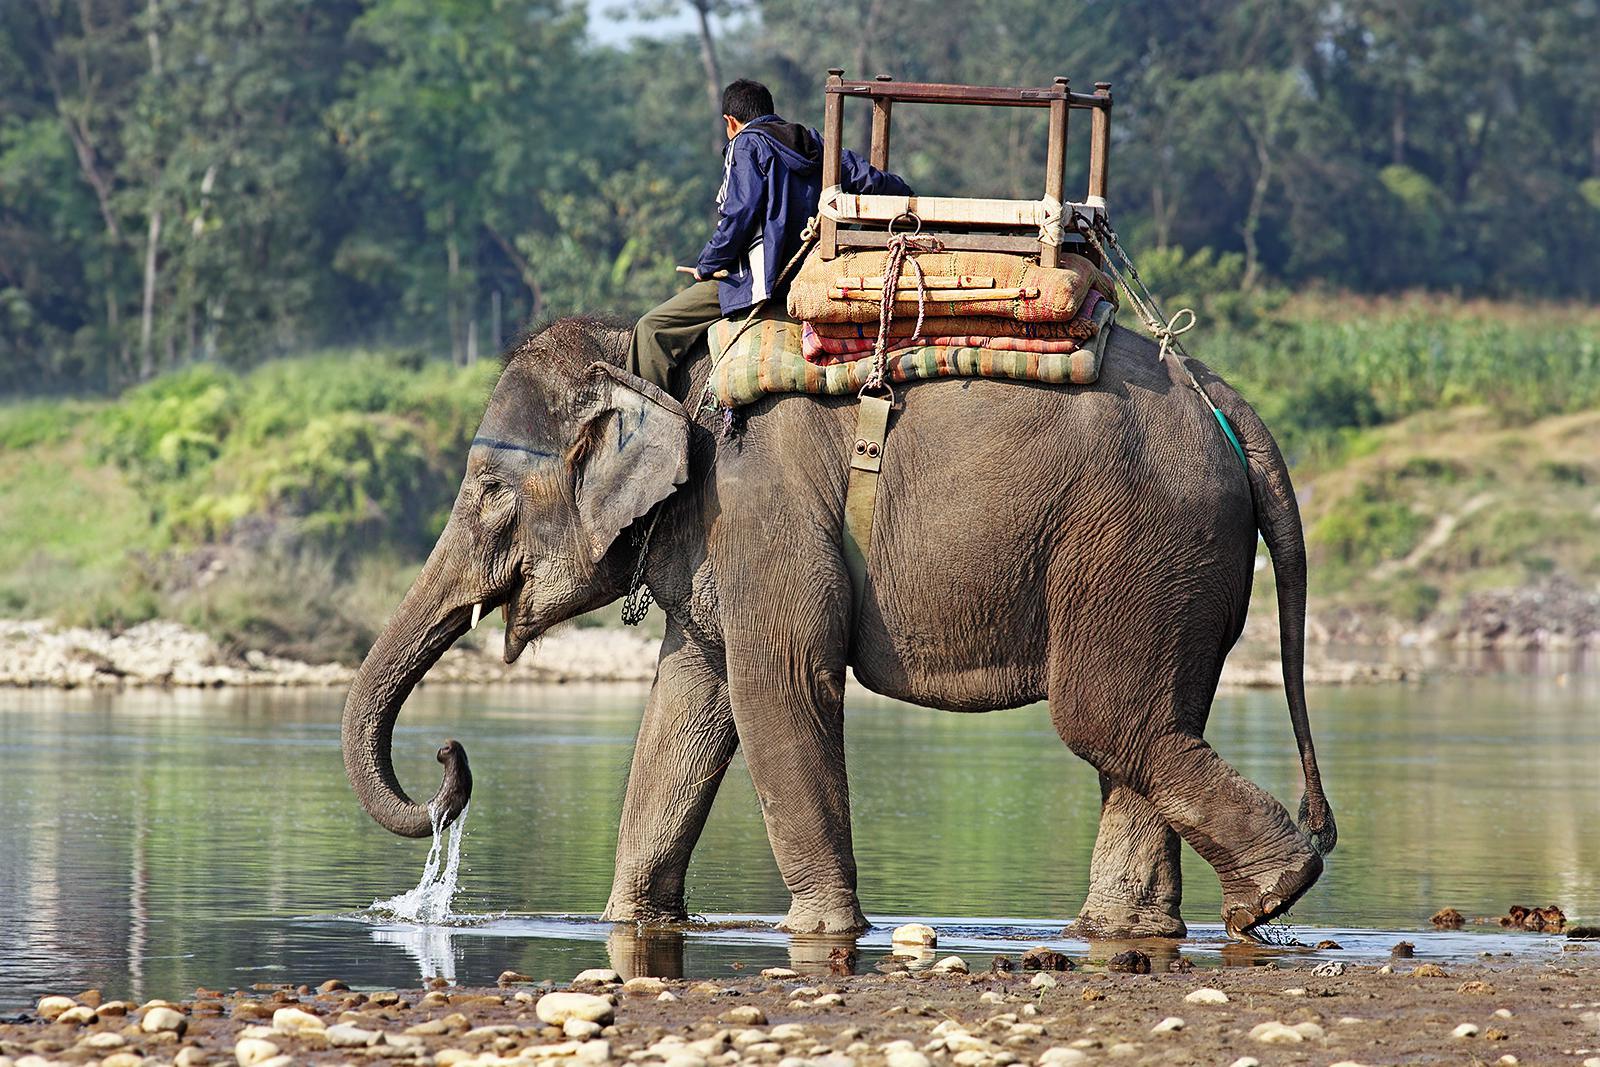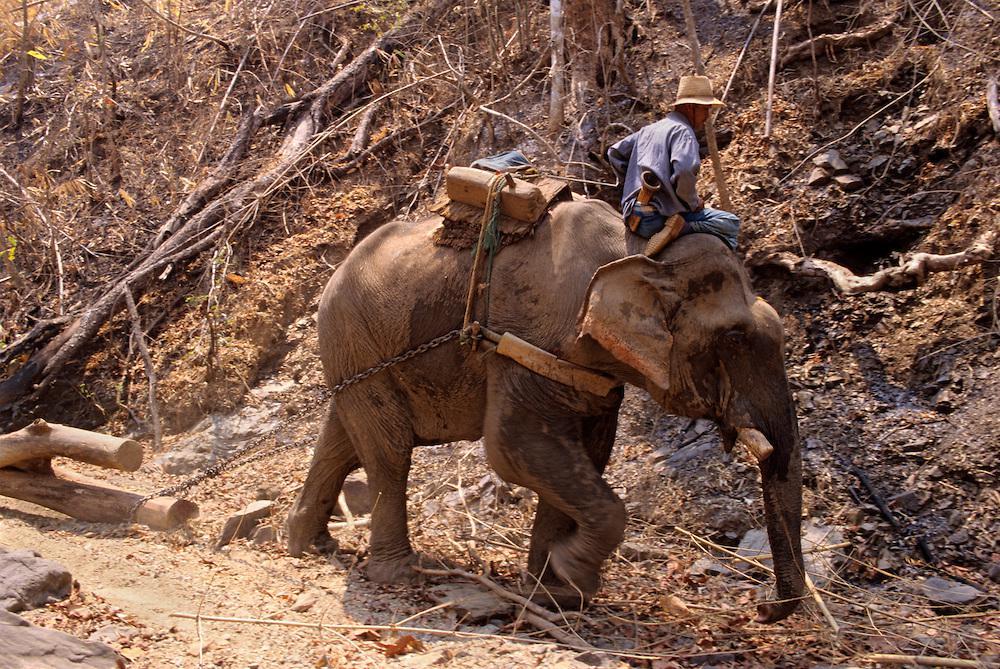The first image is the image on the left, the second image is the image on the right. Evaluate the accuracy of this statement regarding the images: "the elephant on the right image is facing right.". Is it true? Answer yes or no. Yes. 